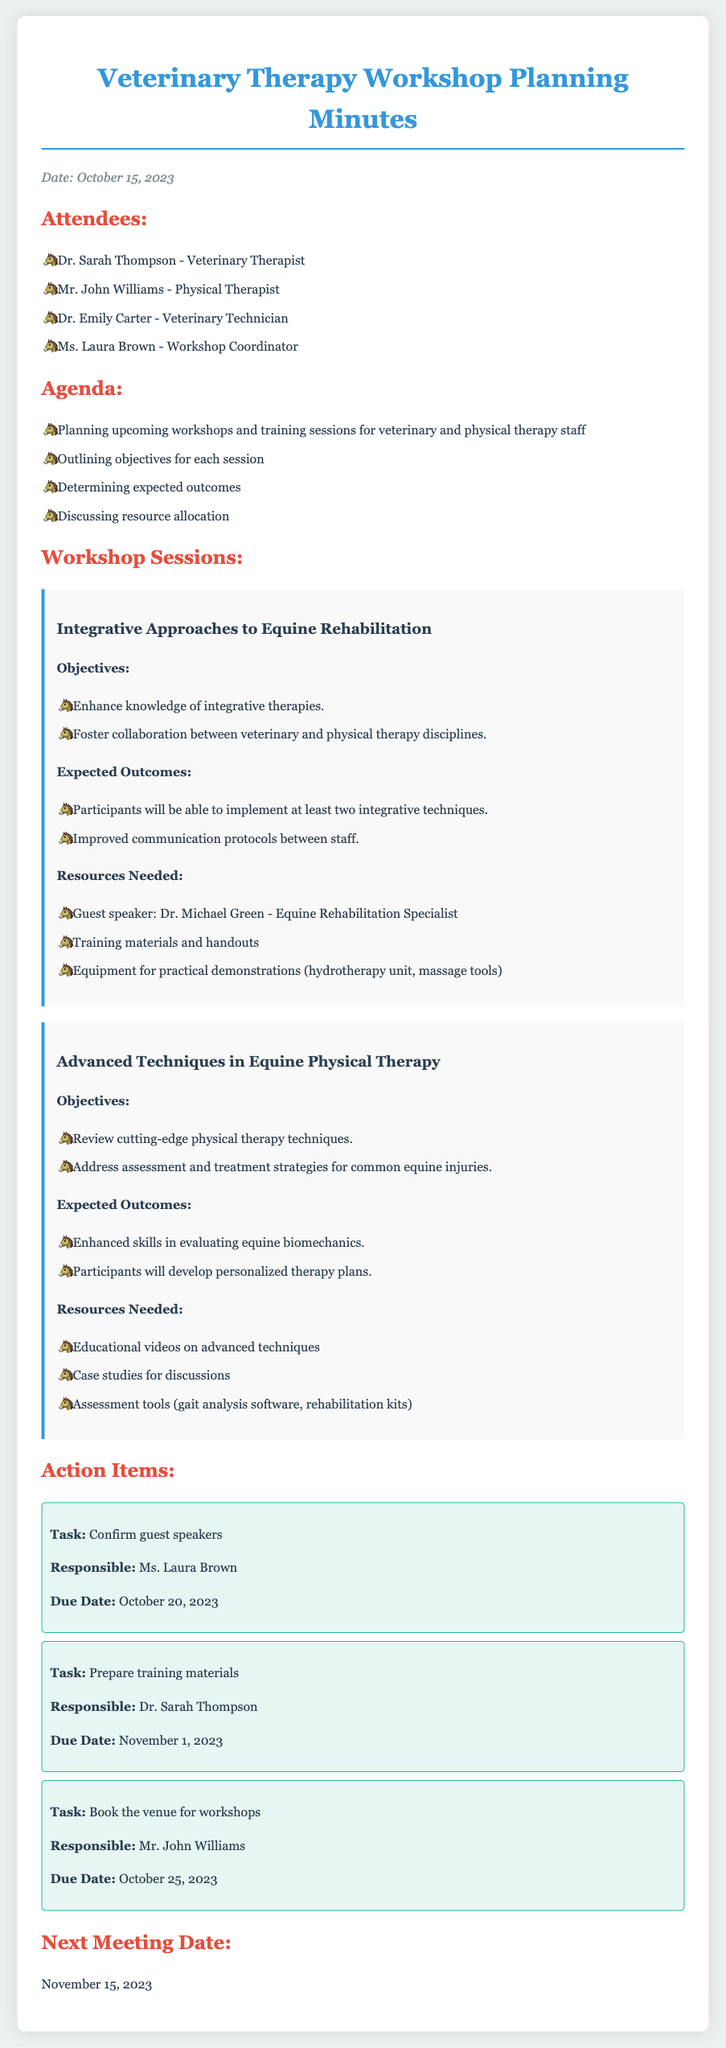What is the date of the meeting? The date of the meeting is mentioned at the top of the document.
Answer: October 15, 2023 Who is responsible for confirming guest speakers? The person responsible for confirming guest speakers is indicated in the action items section.
Answer: Ms. Laura Brown What is one resource needed for the workshop on integrative approaches? The document lists specific resources required for each workshop.
Answer: Guest speaker: Dr. Michael Green - Equine Rehabilitation Specialist What are the expected outcomes of the workshop on advanced techniques? The expected outcomes are listed under each workshop section.
Answer: Enhanced skills in evaluating equine biomechanics When is the next meeting scheduled? The next meeting date is provided at the end of the document.
Answer: November 15, 2023 What is one objective of the workshop on integrative approaches? The objectives are explicitly listed under the respective workshop sections.
Answer: Enhance knowledge of integrative therapies How many attendees are listed in the minutes? The names of attendees are provided in the attendees section of the document.
Answer: Four What is the due date for preparing training materials? The due date for tasks is clearly stated in the action items section.
Answer: November 1, 2023 What is the title of the first workshop listed? The first workshop's title appears prominently in the workshop sessions section.
Answer: Integrative Approaches to Equine Rehabilitation 